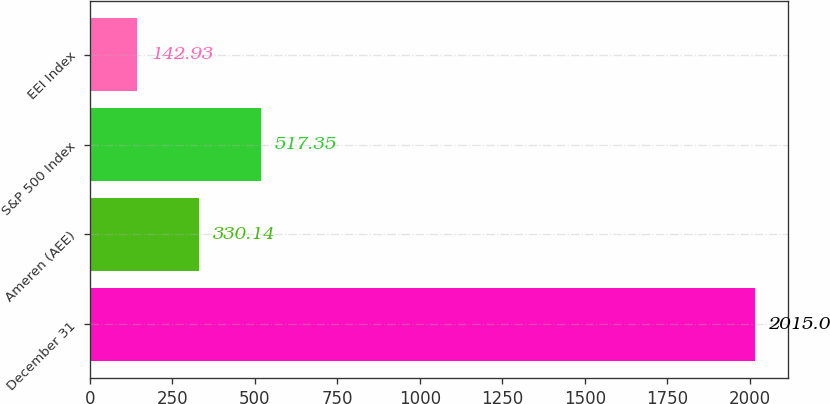Convert chart to OTSL. <chart><loc_0><loc_0><loc_500><loc_500><bar_chart><fcel>December 31<fcel>Ameren (AEE)<fcel>S&P 500 Index<fcel>EEI Index<nl><fcel>2015<fcel>330.14<fcel>517.35<fcel>142.93<nl></chart> 